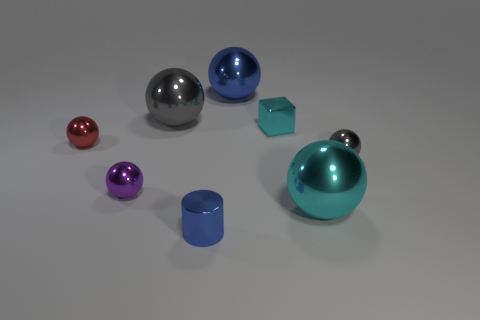Subtract 1 balls. How many balls are left? 5 Subtract all blue balls. How many balls are left? 5 Subtract all large blue metallic balls. How many balls are left? 5 Subtract all cyan spheres. Subtract all yellow cubes. How many spheres are left? 5 Add 1 blue matte spheres. How many objects exist? 9 Subtract all cylinders. How many objects are left? 7 Add 6 tiny cylinders. How many tiny cylinders are left? 7 Add 6 big shiny cylinders. How many big shiny cylinders exist? 6 Subtract 0 green blocks. How many objects are left? 8 Subtract all yellow matte objects. Subtract all cylinders. How many objects are left? 7 